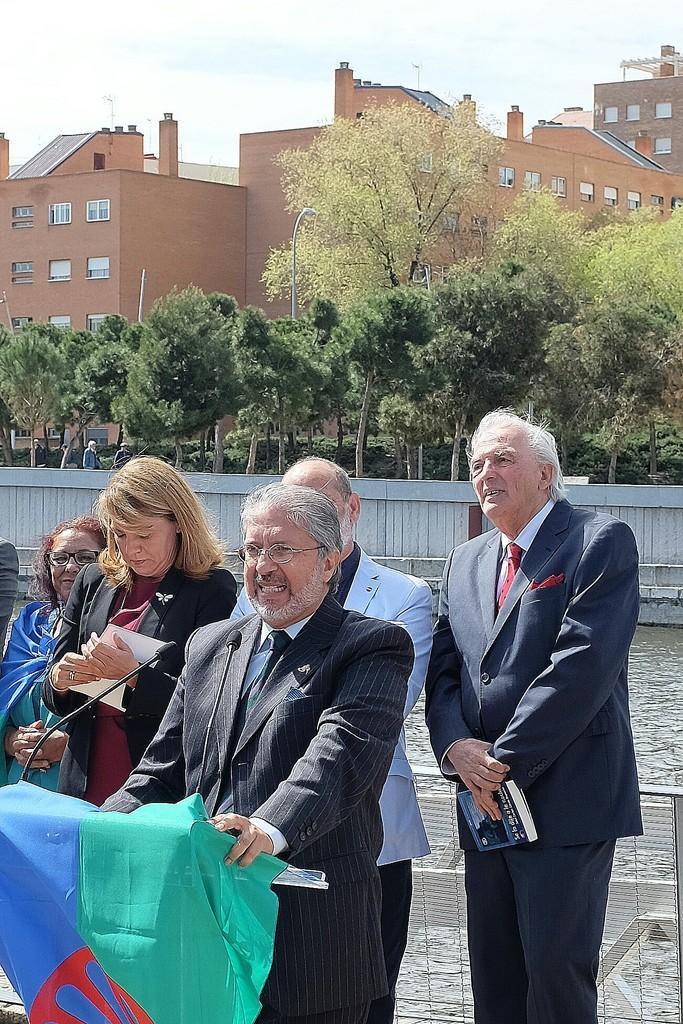Describe this image in one or two sentences. In this image we can see few persons and among them few persons are holding objects. In front of the person we can see a podium with mic and on the podium we can see a flag. Behind the persons we can see the fencing, water and trees. In the background, we can see the buildings. At the top we can see the sky. 